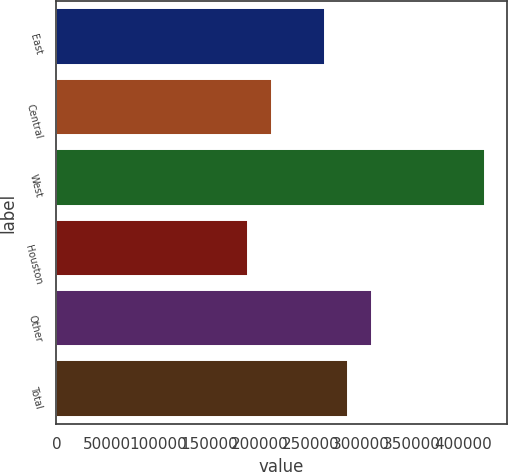Convert chart to OTSL. <chart><loc_0><loc_0><loc_500><loc_500><bar_chart><fcel>East<fcel>Central<fcel>West<fcel>Houston<fcel>Other<fcel>Total<nl><fcel>264000<fcel>212300<fcel>422000<fcel>189000<fcel>310600<fcel>287300<nl></chart> 